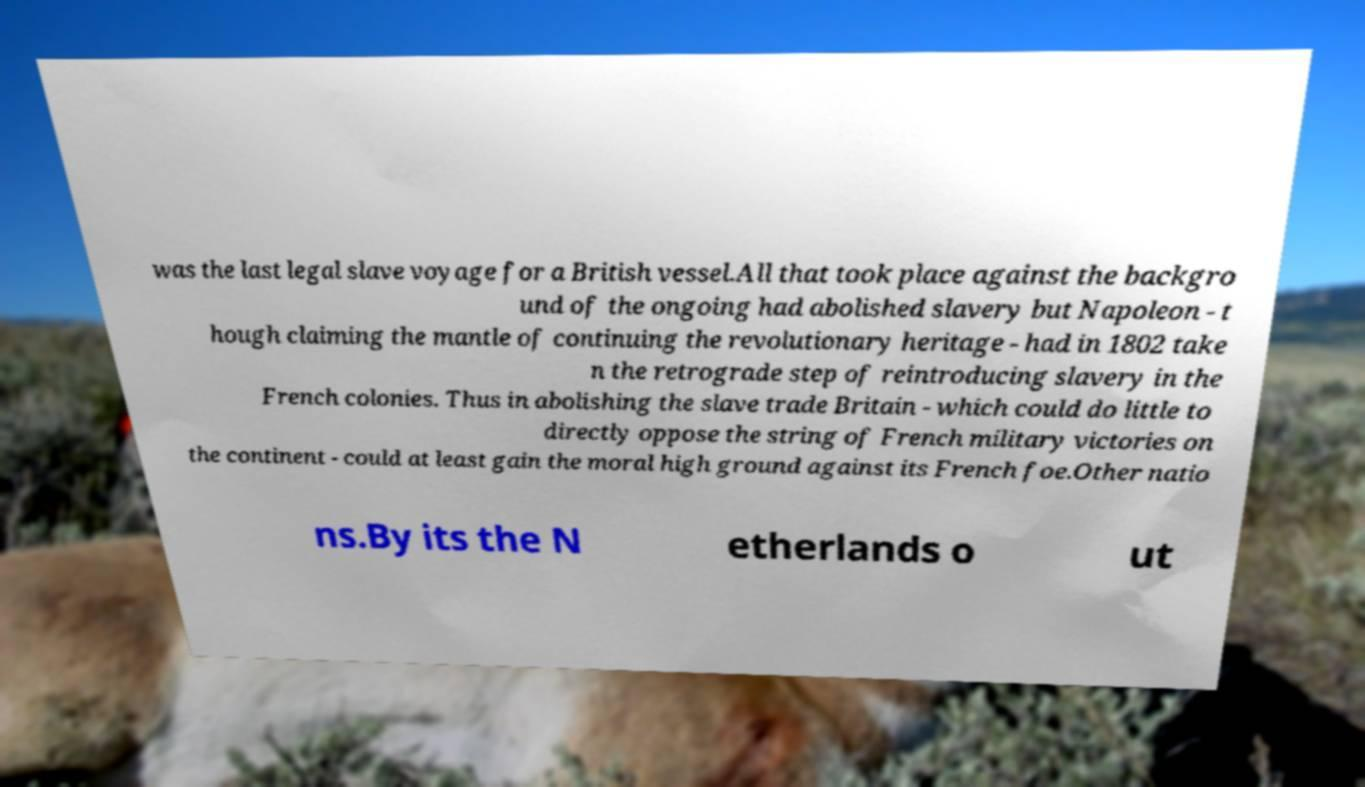I need the written content from this picture converted into text. Can you do that? was the last legal slave voyage for a British vessel.All that took place against the backgro und of the ongoing had abolished slavery but Napoleon - t hough claiming the mantle of continuing the revolutionary heritage - had in 1802 take n the retrograde step of reintroducing slavery in the French colonies. Thus in abolishing the slave trade Britain - which could do little to directly oppose the string of French military victories on the continent - could at least gain the moral high ground against its French foe.Other natio ns.By its the N etherlands o ut 